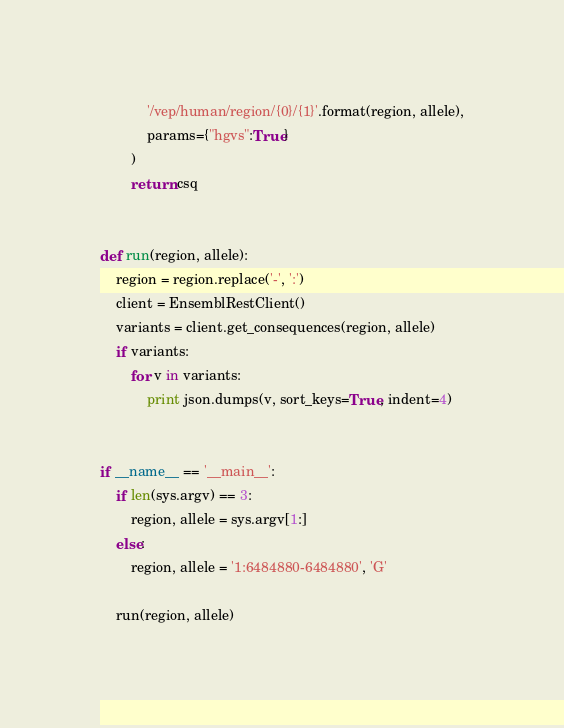<code> <loc_0><loc_0><loc_500><loc_500><_Python_>            '/vep/human/region/{0}/{1}'.format(region, allele),
            params={"hgvs":True}
        )
        return csq


def run(region, allele):
    region = region.replace('-', ':')
    client = EnsemblRestClient()
    variants = client.get_consequences(region, allele)
    if variants:
        for v in variants:
            print json.dumps(v, sort_keys=True, indent=4)


if __name__ == '__main__':
    if len(sys.argv) == 3:
        region, allele = sys.argv[1:]
    else:
        region, allele = '1:6484880-6484880', 'G'

    run(region, allele)

</code> 